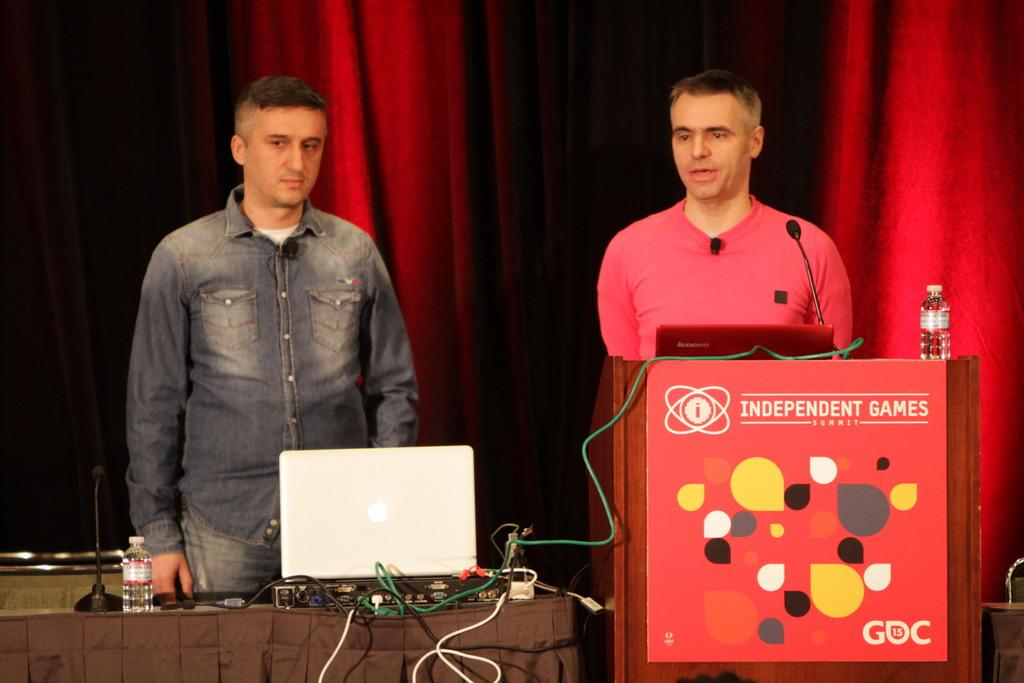How many people are present in the image? There are two people standing in the image. What is one of the people doing in the image? There is a person standing in front of a microphone in the image. Can you describe the setting of the image? The setting is a wooden cabin. What objects are in front of the people in the image? There are two laptops in front of the people. How many ducks are visible in the image? There are no ducks present in the image. What suggestion can be made to improve the lighting in the image? The provided facts do not mention any issues with lighting, so it is not possible to make a suggestion for improvement. 